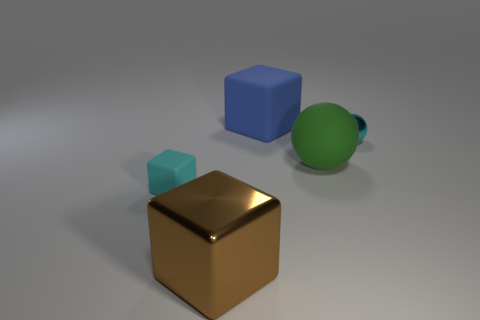Add 4 large blue matte blocks. How many objects exist? 9 Subtract all balls. How many objects are left? 3 Subtract 0 purple cylinders. How many objects are left? 5 Subtract all purple cylinders. Subtract all cyan matte things. How many objects are left? 4 Add 3 big rubber spheres. How many big rubber spheres are left? 4 Add 5 big brown cylinders. How many big brown cylinders exist? 5 